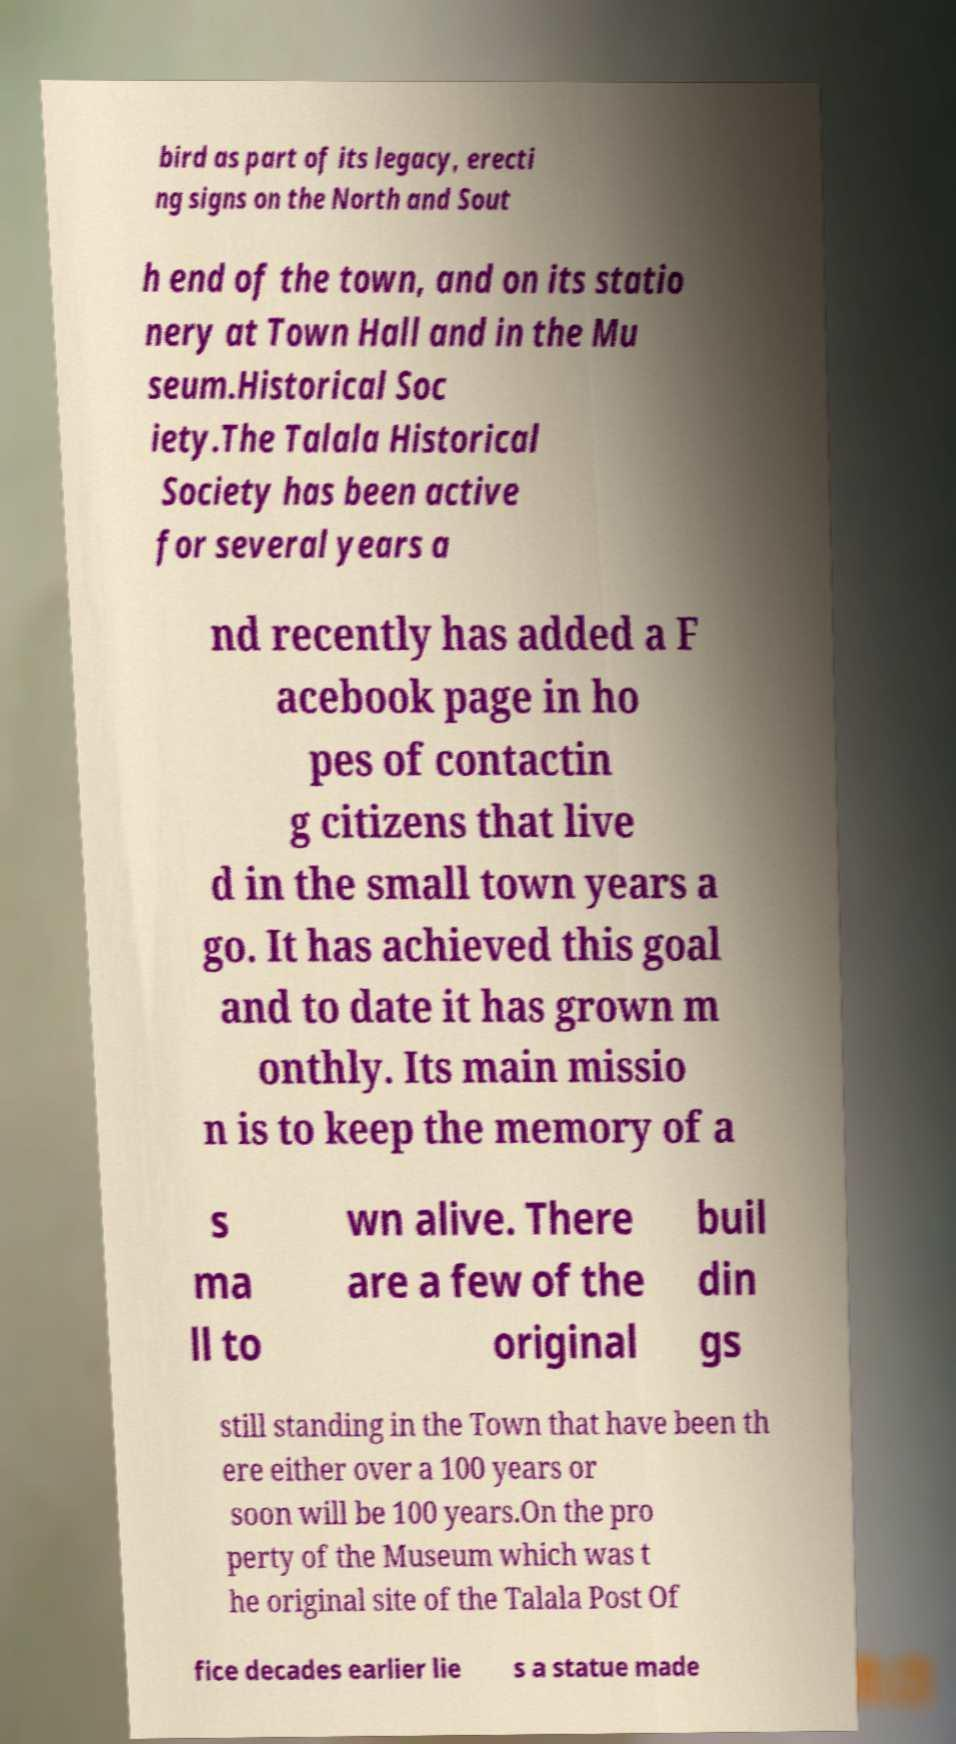I need the written content from this picture converted into text. Can you do that? bird as part of its legacy, erecti ng signs on the North and Sout h end of the town, and on its statio nery at Town Hall and in the Mu seum.Historical Soc iety.The Talala Historical Society has been active for several years a nd recently has added a F acebook page in ho pes of contactin g citizens that live d in the small town years a go. It has achieved this goal and to date it has grown m onthly. Its main missio n is to keep the memory of a s ma ll to wn alive. There are a few of the original buil din gs still standing in the Town that have been th ere either over a 100 years or soon will be 100 years.On the pro perty of the Museum which was t he original site of the Talala Post Of fice decades earlier lie s a statue made 